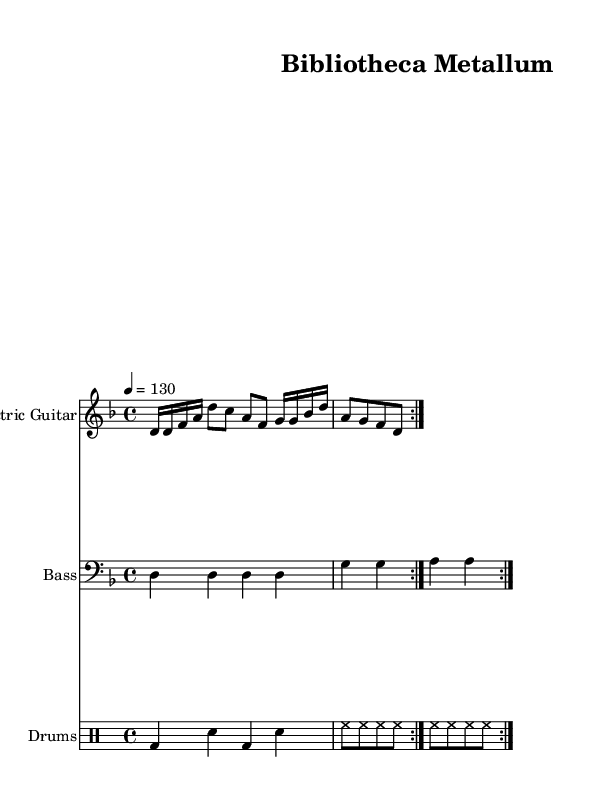What is the key signature of this music? The key signature is indicated at the beginning of the staff, stated as D minor, which has one flat.
Answer: D minor What is the time signature of this piece? The time signature is found at the beginning of the music, displayed as 4/4, meaning there are four beats in each measure and the quarter note gets one beat.
Answer: 4/4 What is the tempo marking of the composition? The tempo marking is located above the staff, denoting that the piece should be played at a speed of 130 beats per minute with a quarter note serving as the beat.
Answer: 130 How many measures are repeated in the guitar part? In the electric guitar part, the text "repeat volta 2" indicates that the measures are repeated twice before moving on.
Answer: 2 What instruments are featured in this score? The score denotes three instruments: Electric Guitar, Bass, and Drums, shown in separate staves for clarity.
Answer: Electric Guitar, Bass, Drums What rhythmic subdivision is primarily used in the drum part? The drum part features eighth-note hi-hat notes, shown as "hh," within a pattern that intersperses bass drum and snare hits, indicating a driving rhythm typical in metal music.
Answer: Eighth notes How does the bass line compare to the guitar line in terms of rhythm? The bass line has steady quarter-note rhythms, contrasting with the guitar line that contains both sixteenth notes and eighth notes, which adds complexity to the overall rhythm.
Answer: Quarter notes vs. mixed rhythms 